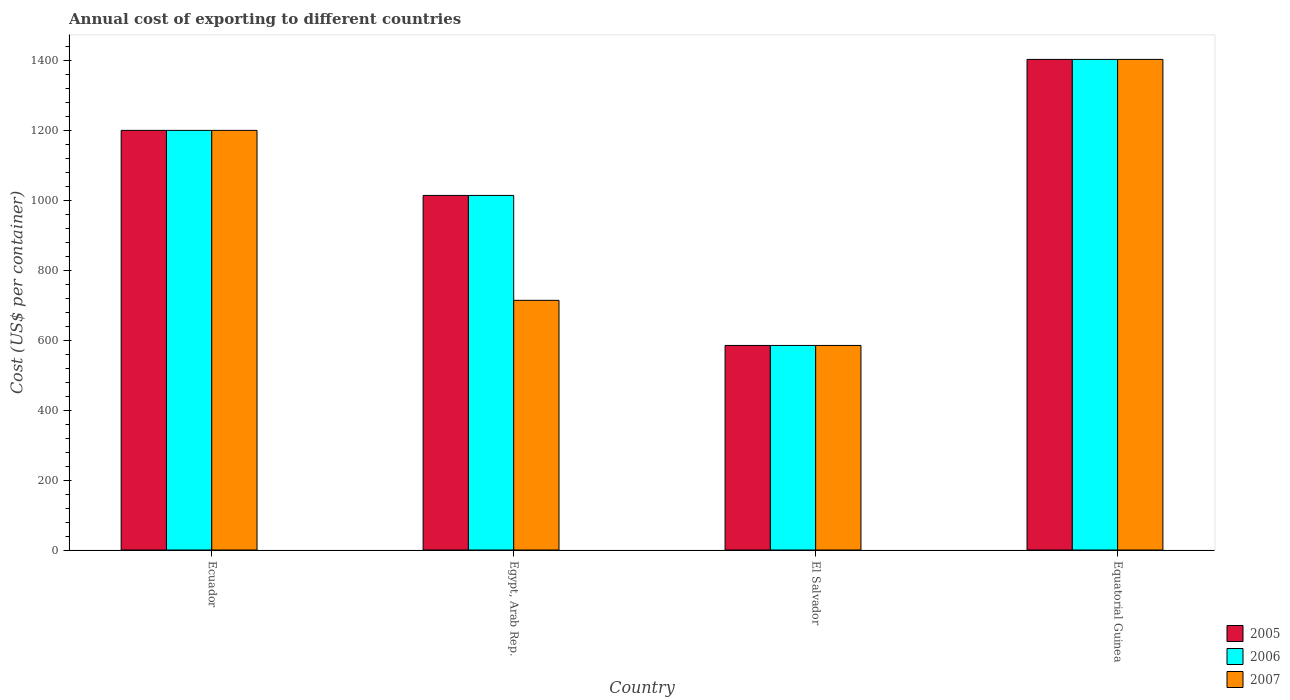How many groups of bars are there?
Provide a short and direct response. 4. Are the number of bars per tick equal to the number of legend labels?
Keep it short and to the point. Yes. Are the number of bars on each tick of the X-axis equal?
Provide a succinct answer. Yes. How many bars are there on the 2nd tick from the left?
Offer a very short reply. 3. How many bars are there on the 3rd tick from the right?
Keep it short and to the point. 3. What is the label of the 1st group of bars from the left?
Offer a very short reply. Ecuador. What is the total annual cost of exporting in 2005 in Equatorial Guinea?
Offer a very short reply. 1403. Across all countries, what is the maximum total annual cost of exporting in 2005?
Keep it short and to the point. 1403. Across all countries, what is the minimum total annual cost of exporting in 2007?
Provide a short and direct response. 585. In which country was the total annual cost of exporting in 2005 maximum?
Offer a terse response. Equatorial Guinea. In which country was the total annual cost of exporting in 2005 minimum?
Make the answer very short. El Salvador. What is the total total annual cost of exporting in 2007 in the graph?
Provide a succinct answer. 3902. What is the difference between the total annual cost of exporting in 2007 in Egypt, Arab Rep. and that in Equatorial Guinea?
Make the answer very short. -689. What is the difference between the total annual cost of exporting in 2007 in Egypt, Arab Rep. and the total annual cost of exporting in 2006 in Ecuador?
Give a very brief answer. -486. What is the average total annual cost of exporting in 2007 per country?
Provide a succinct answer. 975.5. What is the difference between the total annual cost of exporting of/in 2006 and total annual cost of exporting of/in 2007 in El Salvador?
Keep it short and to the point. 0. In how many countries, is the total annual cost of exporting in 2006 greater than 800 US$?
Give a very brief answer. 3. What is the ratio of the total annual cost of exporting in 2007 in Egypt, Arab Rep. to that in Equatorial Guinea?
Offer a very short reply. 0.51. Is the difference between the total annual cost of exporting in 2006 in Ecuador and El Salvador greater than the difference between the total annual cost of exporting in 2007 in Ecuador and El Salvador?
Give a very brief answer. No. What is the difference between the highest and the second highest total annual cost of exporting in 2005?
Your response must be concise. -203. What is the difference between the highest and the lowest total annual cost of exporting in 2006?
Provide a succinct answer. 818. In how many countries, is the total annual cost of exporting in 2007 greater than the average total annual cost of exporting in 2007 taken over all countries?
Provide a succinct answer. 2. What does the 3rd bar from the left in Egypt, Arab Rep. represents?
Offer a terse response. 2007. Are the values on the major ticks of Y-axis written in scientific E-notation?
Give a very brief answer. No. Does the graph contain any zero values?
Keep it short and to the point. No. Does the graph contain grids?
Give a very brief answer. No. What is the title of the graph?
Keep it short and to the point. Annual cost of exporting to different countries. Does "1990" appear as one of the legend labels in the graph?
Offer a very short reply. No. What is the label or title of the X-axis?
Your response must be concise. Country. What is the label or title of the Y-axis?
Make the answer very short. Cost (US$ per container). What is the Cost (US$ per container) in 2005 in Ecuador?
Your response must be concise. 1200. What is the Cost (US$ per container) in 2006 in Ecuador?
Your response must be concise. 1200. What is the Cost (US$ per container) of 2007 in Ecuador?
Ensure brevity in your answer.  1200. What is the Cost (US$ per container) of 2005 in Egypt, Arab Rep.?
Ensure brevity in your answer.  1014. What is the Cost (US$ per container) of 2006 in Egypt, Arab Rep.?
Your answer should be very brief. 1014. What is the Cost (US$ per container) in 2007 in Egypt, Arab Rep.?
Keep it short and to the point. 714. What is the Cost (US$ per container) in 2005 in El Salvador?
Ensure brevity in your answer.  585. What is the Cost (US$ per container) of 2006 in El Salvador?
Offer a terse response. 585. What is the Cost (US$ per container) of 2007 in El Salvador?
Your answer should be very brief. 585. What is the Cost (US$ per container) of 2005 in Equatorial Guinea?
Your response must be concise. 1403. What is the Cost (US$ per container) in 2006 in Equatorial Guinea?
Offer a very short reply. 1403. What is the Cost (US$ per container) in 2007 in Equatorial Guinea?
Ensure brevity in your answer.  1403. Across all countries, what is the maximum Cost (US$ per container) of 2005?
Offer a terse response. 1403. Across all countries, what is the maximum Cost (US$ per container) in 2006?
Your answer should be compact. 1403. Across all countries, what is the maximum Cost (US$ per container) in 2007?
Provide a short and direct response. 1403. Across all countries, what is the minimum Cost (US$ per container) of 2005?
Your response must be concise. 585. Across all countries, what is the minimum Cost (US$ per container) of 2006?
Give a very brief answer. 585. Across all countries, what is the minimum Cost (US$ per container) of 2007?
Keep it short and to the point. 585. What is the total Cost (US$ per container) in 2005 in the graph?
Keep it short and to the point. 4202. What is the total Cost (US$ per container) of 2006 in the graph?
Your answer should be very brief. 4202. What is the total Cost (US$ per container) in 2007 in the graph?
Offer a very short reply. 3902. What is the difference between the Cost (US$ per container) of 2005 in Ecuador and that in Egypt, Arab Rep.?
Keep it short and to the point. 186. What is the difference between the Cost (US$ per container) of 2006 in Ecuador and that in Egypt, Arab Rep.?
Your response must be concise. 186. What is the difference between the Cost (US$ per container) of 2007 in Ecuador and that in Egypt, Arab Rep.?
Your answer should be compact. 486. What is the difference between the Cost (US$ per container) in 2005 in Ecuador and that in El Salvador?
Keep it short and to the point. 615. What is the difference between the Cost (US$ per container) of 2006 in Ecuador and that in El Salvador?
Your answer should be very brief. 615. What is the difference between the Cost (US$ per container) in 2007 in Ecuador and that in El Salvador?
Your response must be concise. 615. What is the difference between the Cost (US$ per container) in 2005 in Ecuador and that in Equatorial Guinea?
Ensure brevity in your answer.  -203. What is the difference between the Cost (US$ per container) in 2006 in Ecuador and that in Equatorial Guinea?
Give a very brief answer. -203. What is the difference between the Cost (US$ per container) of 2007 in Ecuador and that in Equatorial Guinea?
Provide a short and direct response. -203. What is the difference between the Cost (US$ per container) in 2005 in Egypt, Arab Rep. and that in El Salvador?
Offer a terse response. 429. What is the difference between the Cost (US$ per container) in 2006 in Egypt, Arab Rep. and that in El Salvador?
Your response must be concise. 429. What is the difference between the Cost (US$ per container) of 2007 in Egypt, Arab Rep. and that in El Salvador?
Offer a terse response. 129. What is the difference between the Cost (US$ per container) of 2005 in Egypt, Arab Rep. and that in Equatorial Guinea?
Your answer should be very brief. -389. What is the difference between the Cost (US$ per container) in 2006 in Egypt, Arab Rep. and that in Equatorial Guinea?
Provide a succinct answer. -389. What is the difference between the Cost (US$ per container) in 2007 in Egypt, Arab Rep. and that in Equatorial Guinea?
Keep it short and to the point. -689. What is the difference between the Cost (US$ per container) in 2005 in El Salvador and that in Equatorial Guinea?
Provide a succinct answer. -818. What is the difference between the Cost (US$ per container) in 2006 in El Salvador and that in Equatorial Guinea?
Provide a succinct answer. -818. What is the difference between the Cost (US$ per container) in 2007 in El Salvador and that in Equatorial Guinea?
Your answer should be very brief. -818. What is the difference between the Cost (US$ per container) in 2005 in Ecuador and the Cost (US$ per container) in 2006 in Egypt, Arab Rep.?
Your answer should be compact. 186. What is the difference between the Cost (US$ per container) of 2005 in Ecuador and the Cost (US$ per container) of 2007 in Egypt, Arab Rep.?
Your answer should be very brief. 486. What is the difference between the Cost (US$ per container) of 2006 in Ecuador and the Cost (US$ per container) of 2007 in Egypt, Arab Rep.?
Offer a terse response. 486. What is the difference between the Cost (US$ per container) in 2005 in Ecuador and the Cost (US$ per container) in 2006 in El Salvador?
Offer a very short reply. 615. What is the difference between the Cost (US$ per container) in 2005 in Ecuador and the Cost (US$ per container) in 2007 in El Salvador?
Offer a very short reply. 615. What is the difference between the Cost (US$ per container) in 2006 in Ecuador and the Cost (US$ per container) in 2007 in El Salvador?
Give a very brief answer. 615. What is the difference between the Cost (US$ per container) of 2005 in Ecuador and the Cost (US$ per container) of 2006 in Equatorial Guinea?
Your answer should be compact. -203. What is the difference between the Cost (US$ per container) in 2005 in Ecuador and the Cost (US$ per container) in 2007 in Equatorial Guinea?
Your answer should be very brief. -203. What is the difference between the Cost (US$ per container) of 2006 in Ecuador and the Cost (US$ per container) of 2007 in Equatorial Guinea?
Give a very brief answer. -203. What is the difference between the Cost (US$ per container) in 2005 in Egypt, Arab Rep. and the Cost (US$ per container) in 2006 in El Salvador?
Your response must be concise. 429. What is the difference between the Cost (US$ per container) in 2005 in Egypt, Arab Rep. and the Cost (US$ per container) in 2007 in El Salvador?
Provide a short and direct response. 429. What is the difference between the Cost (US$ per container) in 2006 in Egypt, Arab Rep. and the Cost (US$ per container) in 2007 in El Salvador?
Provide a succinct answer. 429. What is the difference between the Cost (US$ per container) of 2005 in Egypt, Arab Rep. and the Cost (US$ per container) of 2006 in Equatorial Guinea?
Keep it short and to the point. -389. What is the difference between the Cost (US$ per container) in 2005 in Egypt, Arab Rep. and the Cost (US$ per container) in 2007 in Equatorial Guinea?
Your response must be concise. -389. What is the difference between the Cost (US$ per container) of 2006 in Egypt, Arab Rep. and the Cost (US$ per container) of 2007 in Equatorial Guinea?
Give a very brief answer. -389. What is the difference between the Cost (US$ per container) in 2005 in El Salvador and the Cost (US$ per container) in 2006 in Equatorial Guinea?
Your answer should be very brief. -818. What is the difference between the Cost (US$ per container) in 2005 in El Salvador and the Cost (US$ per container) in 2007 in Equatorial Guinea?
Ensure brevity in your answer.  -818. What is the difference between the Cost (US$ per container) of 2006 in El Salvador and the Cost (US$ per container) of 2007 in Equatorial Guinea?
Keep it short and to the point. -818. What is the average Cost (US$ per container) of 2005 per country?
Make the answer very short. 1050.5. What is the average Cost (US$ per container) in 2006 per country?
Offer a terse response. 1050.5. What is the average Cost (US$ per container) of 2007 per country?
Offer a very short reply. 975.5. What is the difference between the Cost (US$ per container) in 2005 and Cost (US$ per container) in 2006 in Ecuador?
Provide a succinct answer. 0. What is the difference between the Cost (US$ per container) in 2005 and Cost (US$ per container) in 2006 in Egypt, Arab Rep.?
Offer a very short reply. 0. What is the difference between the Cost (US$ per container) of 2005 and Cost (US$ per container) of 2007 in Egypt, Arab Rep.?
Your answer should be compact. 300. What is the difference between the Cost (US$ per container) in 2006 and Cost (US$ per container) in 2007 in Egypt, Arab Rep.?
Make the answer very short. 300. What is the difference between the Cost (US$ per container) in 2005 and Cost (US$ per container) in 2006 in Equatorial Guinea?
Keep it short and to the point. 0. What is the difference between the Cost (US$ per container) of 2005 and Cost (US$ per container) of 2007 in Equatorial Guinea?
Your response must be concise. 0. What is the ratio of the Cost (US$ per container) in 2005 in Ecuador to that in Egypt, Arab Rep.?
Offer a very short reply. 1.18. What is the ratio of the Cost (US$ per container) in 2006 in Ecuador to that in Egypt, Arab Rep.?
Keep it short and to the point. 1.18. What is the ratio of the Cost (US$ per container) in 2007 in Ecuador to that in Egypt, Arab Rep.?
Ensure brevity in your answer.  1.68. What is the ratio of the Cost (US$ per container) in 2005 in Ecuador to that in El Salvador?
Provide a short and direct response. 2.05. What is the ratio of the Cost (US$ per container) in 2006 in Ecuador to that in El Salvador?
Your answer should be compact. 2.05. What is the ratio of the Cost (US$ per container) in 2007 in Ecuador to that in El Salvador?
Your answer should be compact. 2.05. What is the ratio of the Cost (US$ per container) of 2005 in Ecuador to that in Equatorial Guinea?
Your answer should be compact. 0.86. What is the ratio of the Cost (US$ per container) in 2006 in Ecuador to that in Equatorial Guinea?
Ensure brevity in your answer.  0.86. What is the ratio of the Cost (US$ per container) of 2007 in Ecuador to that in Equatorial Guinea?
Your answer should be very brief. 0.86. What is the ratio of the Cost (US$ per container) in 2005 in Egypt, Arab Rep. to that in El Salvador?
Your answer should be compact. 1.73. What is the ratio of the Cost (US$ per container) in 2006 in Egypt, Arab Rep. to that in El Salvador?
Your answer should be very brief. 1.73. What is the ratio of the Cost (US$ per container) in 2007 in Egypt, Arab Rep. to that in El Salvador?
Provide a succinct answer. 1.22. What is the ratio of the Cost (US$ per container) of 2005 in Egypt, Arab Rep. to that in Equatorial Guinea?
Make the answer very short. 0.72. What is the ratio of the Cost (US$ per container) in 2006 in Egypt, Arab Rep. to that in Equatorial Guinea?
Offer a very short reply. 0.72. What is the ratio of the Cost (US$ per container) of 2007 in Egypt, Arab Rep. to that in Equatorial Guinea?
Make the answer very short. 0.51. What is the ratio of the Cost (US$ per container) in 2005 in El Salvador to that in Equatorial Guinea?
Your response must be concise. 0.42. What is the ratio of the Cost (US$ per container) in 2006 in El Salvador to that in Equatorial Guinea?
Keep it short and to the point. 0.42. What is the ratio of the Cost (US$ per container) of 2007 in El Salvador to that in Equatorial Guinea?
Your answer should be compact. 0.42. What is the difference between the highest and the second highest Cost (US$ per container) of 2005?
Provide a succinct answer. 203. What is the difference between the highest and the second highest Cost (US$ per container) of 2006?
Ensure brevity in your answer.  203. What is the difference between the highest and the second highest Cost (US$ per container) in 2007?
Your response must be concise. 203. What is the difference between the highest and the lowest Cost (US$ per container) in 2005?
Your answer should be very brief. 818. What is the difference between the highest and the lowest Cost (US$ per container) in 2006?
Your response must be concise. 818. What is the difference between the highest and the lowest Cost (US$ per container) in 2007?
Make the answer very short. 818. 